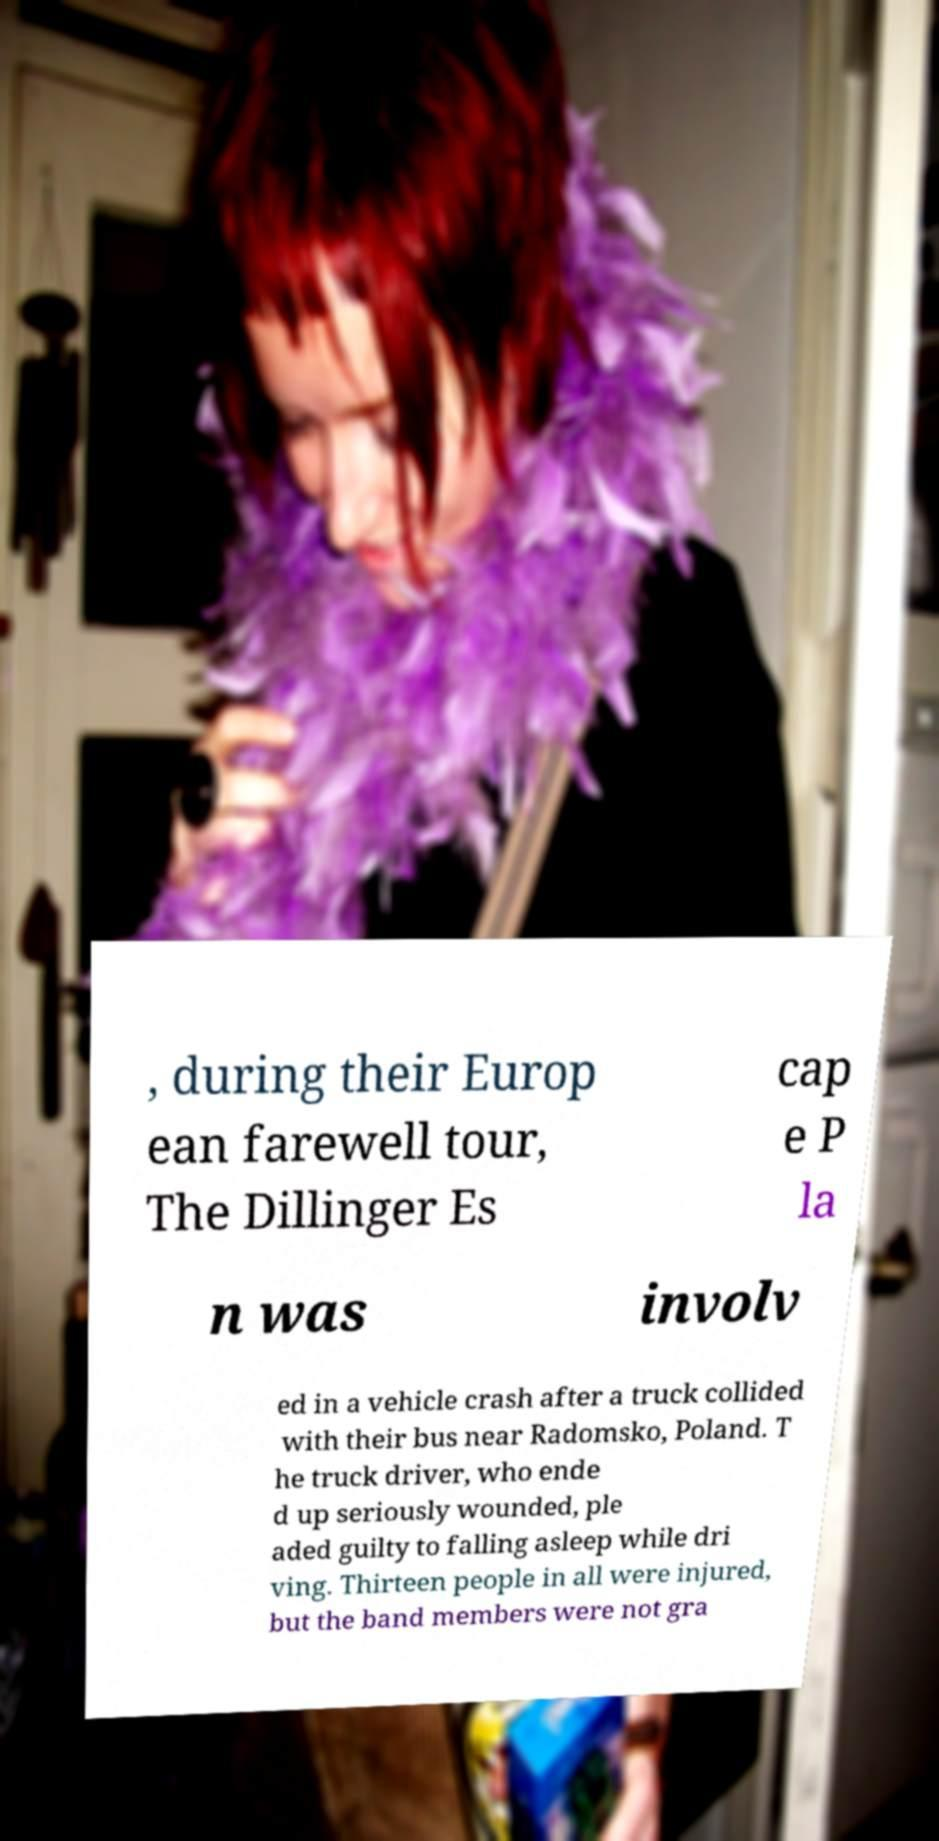For documentation purposes, I need the text within this image transcribed. Could you provide that? , during their Europ ean farewell tour, The Dillinger Es cap e P la n was involv ed in a vehicle crash after a truck collided with their bus near Radomsko, Poland. T he truck driver, who ende d up seriously wounded, ple aded guilty to falling asleep while dri ving. Thirteen people in all were injured, but the band members were not gra 